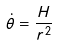<formula> <loc_0><loc_0><loc_500><loc_500>\dot { \theta } = \frac { H } { r ^ { 2 } }</formula> 